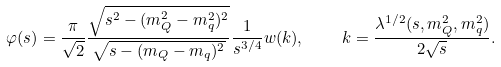Convert formula to latex. <formula><loc_0><loc_0><loc_500><loc_500>\varphi ( s ) = \frac { \pi } { \sqrt { 2 } } \frac { \sqrt { s ^ { 2 } - ( m _ { Q } ^ { 2 } - m _ { q } ^ { 2 } ) ^ { 2 } } } { \sqrt { s - ( m _ { Q } - m _ { q } ) ^ { 2 } } } \frac { 1 } { s ^ { 3 / 4 } } w ( k ) , \quad k = \frac { \lambda ^ { 1 / 2 } ( s , m _ { Q } ^ { 2 } , m _ { q } ^ { 2 } ) } { 2 \sqrt { s } } .</formula> 